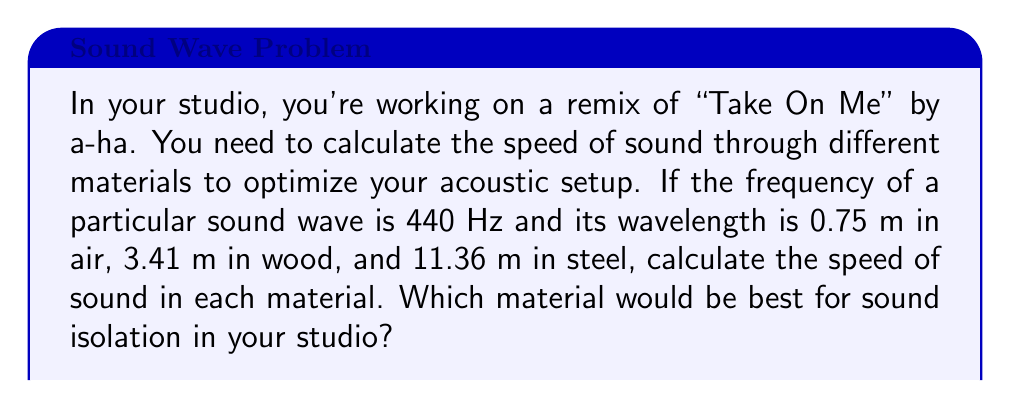Teach me how to tackle this problem. To solve this problem, we'll use the wave equation:

$$ v = f \lambda $$

Where:
$v$ = speed of sound
$f$ = frequency
$\lambda$ = wavelength

Given:
$f = 440$ Hz
$\lambda_{air} = 0.75$ m
$\lambda_{wood} = 3.41$ m
$\lambda_{steel} = 11.36$ m

Step 1: Calculate the speed of sound in air
$$ v_{air} = f \lambda_{air} = 440 \text{ Hz} \times 0.75 \text{ m} = 330 \text{ m/s} $$

Step 2: Calculate the speed of sound in wood
$$ v_{wood} = f \lambda_{wood} = 440 \text{ Hz} \times 3.41 \text{ m} = 1500.4 \text{ m/s} $$

Step 3: Calculate the speed of sound in steel
$$ v_{steel} = f \lambda_{steel} = 440 \text{ Hz} \times 11.36 \text{ m} = 4998.4 \text{ m/s} $$

Step 4: Compare the speeds

The speed of sound is highest in steel, followed by wood, and then air. For sound isolation, we want to use a material that reflects sound waves rather than allowing them to pass through easily. Materials with higher sound speeds tend to be denser and more rigid, making them better at reflecting sound.

Therefore, steel would be the best material for sound isolation in the studio, as it has the highest speed of sound among the given materials.
Answer: Air: 330 m/s, Wood: 1500.4 m/s, Steel: 4998.4 m/s. Steel is best for isolation. 